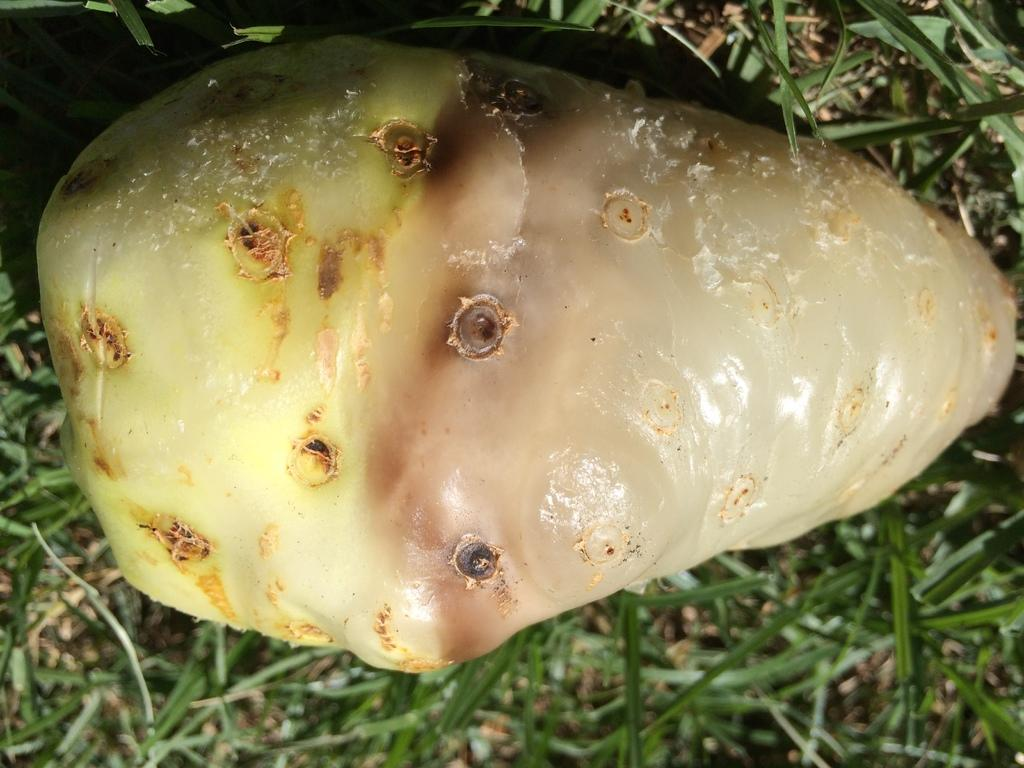What type of food can be seen in the image? There is a vegetable in the image. What color is the grass in the image? There is green grass in the image. What month is it in the image? The month cannot be determined from the image, as it only shows a vegetable and green grass. Can you see any ducks in the image? There are no ducks present in the image. 